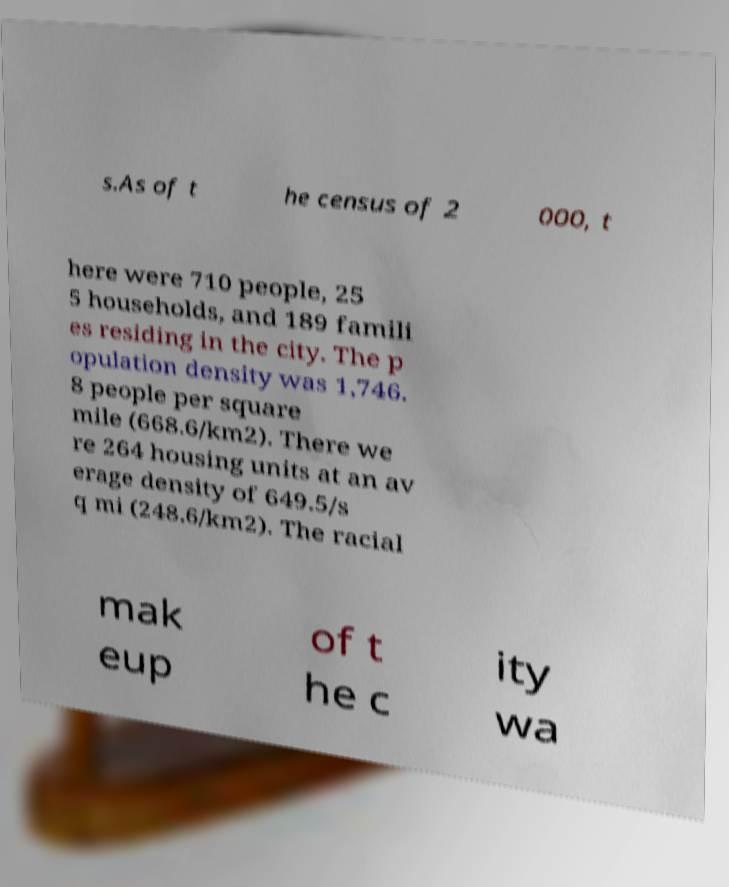Can you accurately transcribe the text from the provided image for me? s.As of t he census of 2 000, t here were 710 people, 25 5 households, and 189 famili es residing in the city. The p opulation density was 1,746. 8 people per square mile (668.6/km2). There we re 264 housing units at an av erage density of 649.5/s q mi (248.6/km2). The racial mak eup of t he c ity wa 